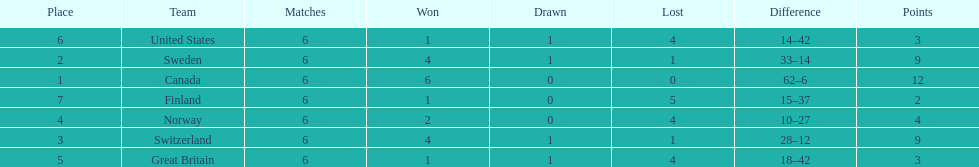What team placed after canada? Sweden. 